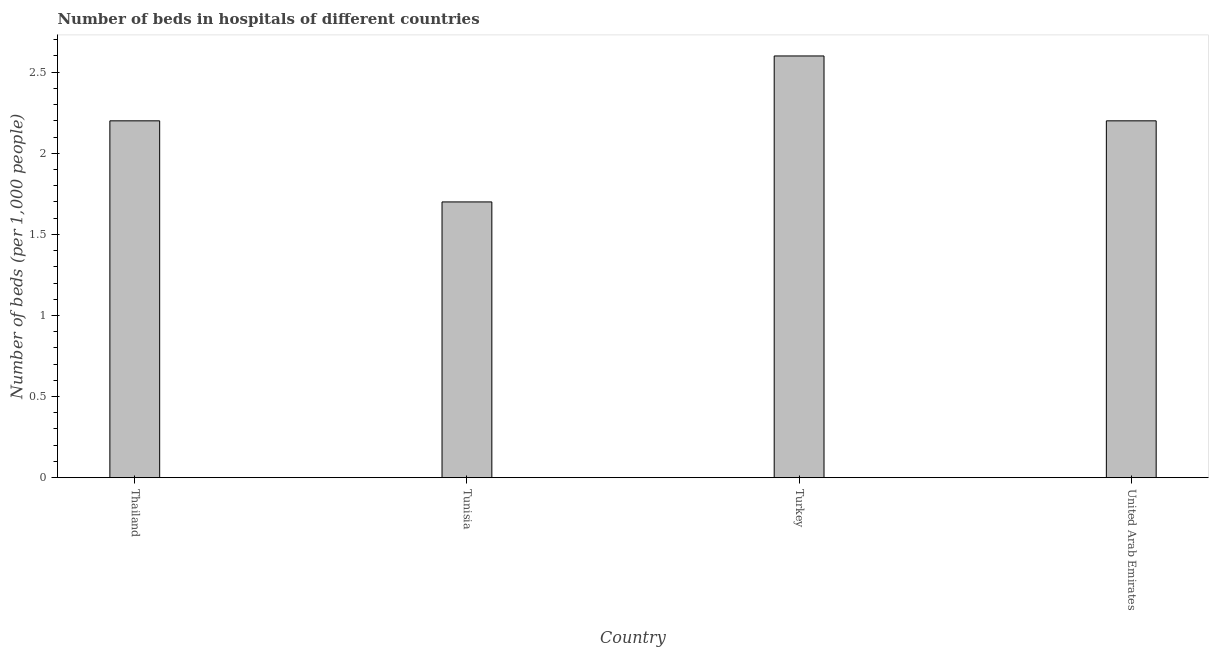Does the graph contain grids?
Provide a short and direct response. No. What is the title of the graph?
Give a very brief answer. Number of beds in hospitals of different countries. What is the label or title of the X-axis?
Keep it short and to the point. Country. What is the label or title of the Y-axis?
Ensure brevity in your answer.  Number of beds (per 1,0 people). What is the number of hospital beds in Turkey?
Ensure brevity in your answer.  2.6. Across all countries, what is the maximum number of hospital beds?
Offer a terse response. 2.6. Across all countries, what is the minimum number of hospital beds?
Provide a short and direct response. 1.7. In which country was the number of hospital beds minimum?
Provide a short and direct response. Tunisia. What is the sum of the number of hospital beds?
Make the answer very short. 8.7. What is the difference between the number of hospital beds in Thailand and United Arab Emirates?
Offer a terse response. 0. What is the average number of hospital beds per country?
Your answer should be very brief. 2.17. In how many countries, is the number of hospital beds greater than 2 %?
Provide a short and direct response. 3. What is the ratio of the number of hospital beds in Thailand to that in Tunisia?
Ensure brevity in your answer.  1.29. Is the difference between the number of hospital beds in Thailand and Turkey greater than the difference between any two countries?
Provide a short and direct response. No. What is the difference between the highest and the second highest number of hospital beds?
Give a very brief answer. 0.4. What is the difference between the highest and the lowest number of hospital beds?
Offer a very short reply. 0.9. In how many countries, is the number of hospital beds greater than the average number of hospital beds taken over all countries?
Offer a very short reply. 3. Are all the bars in the graph horizontal?
Offer a very short reply. No. How many countries are there in the graph?
Make the answer very short. 4. Are the values on the major ticks of Y-axis written in scientific E-notation?
Offer a terse response. No. What is the Number of beds (per 1,000 people) of Thailand?
Offer a very short reply. 2.2. What is the Number of beds (per 1,000 people) in Tunisia?
Offer a very short reply. 1.7. What is the Number of beds (per 1,000 people) in Turkey?
Provide a succinct answer. 2.6. What is the difference between the Number of beds (per 1,000 people) in Thailand and Tunisia?
Your answer should be very brief. 0.5. What is the difference between the Number of beds (per 1,000 people) in Thailand and United Arab Emirates?
Your answer should be compact. 0. What is the difference between the Number of beds (per 1,000 people) in Tunisia and Turkey?
Your answer should be compact. -0.9. What is the ratio of the Number of beds (per 1,000 people) in Thailand to that in Tunisia?
Make the answer very short. 1.29. What is the ratio of the Number of beds (per 1,000 people) in Thailand to that in Turkey?
Provide a short and direct response. 0.85. What is the ratio of the Number of beds (per 1,000 people) in Tunisia to that in Turkey?
Make the answer very short. 0.65. What is the ratio of the Number of beds (per 1,000 people) in Tunisia to that in United Arab Emirates?
Your answer should be compact. 0.77. What is the ratio of the Number of beds (per 1,000 people) in Turkey to that in United Arab Emirates?
Offer a terse response. 1.18. 